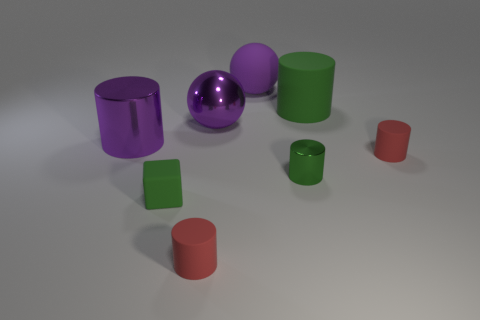There is a red rubber cylinder that is to the left of the metallic cylinder right of the small green rubber block; are there any large metal spheres that are left of it?
Make the answer very short. No. There is a purple sphere that is made of the same material as the green cube; what is its size?
Your response must be concise. Large. Are there any tiny cylinders left of the tiny block?
Your answer should be very brief. No. Are there any big things in front of the matte object behind the large green matte thing?
Your response must be concise. Yes. Do the red rubber thing that is left of the green metallic cylinder and the shiny thing to the right of the matte ball have the same size?
Your answer should be compact. Yes. What number of tiny objects are either green cubes or red objects?
Your response must be concise. 3. The tiny red object that is on the left side of the large purple rubber ball left of the big green cylinder is made of what material?
Your response must be concise. Rubber. What is the shape of the large matte object that is the same color as the shiny ball?
Your answer should be compact. Sphere. Are there any tiny red objects that have the same material as the block?
Provide a short and direct response. Yes. Does the big green thing have the same material as the large cylinder left of the big matte ball?
Offer a very short reply. No. 